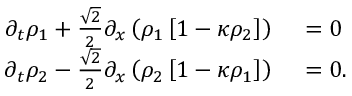Convert formula to latex. <formula><loc_0><loc_0><loc_500><loc_500>\begin{array} { r l } { \partial _ { t } \rho _ { 1 } + \frac { \sqrt { 2 } } { 2 } \partial _ { x } \left ( \rho _ { 1 } \left [ 1 - \kappa \rho _ { 2 } \right ] \right } & 0 } \\ { \partial _ { t } \rho _ { 2 } - \frac { \sqrt { 2 } } { 2 } \partial _ { x } \left ( \rho _ { 2 } \left [ 1 - \kappa \rho _ { 1 } \right ] \right } & 0 . } \end{array}</formula> 